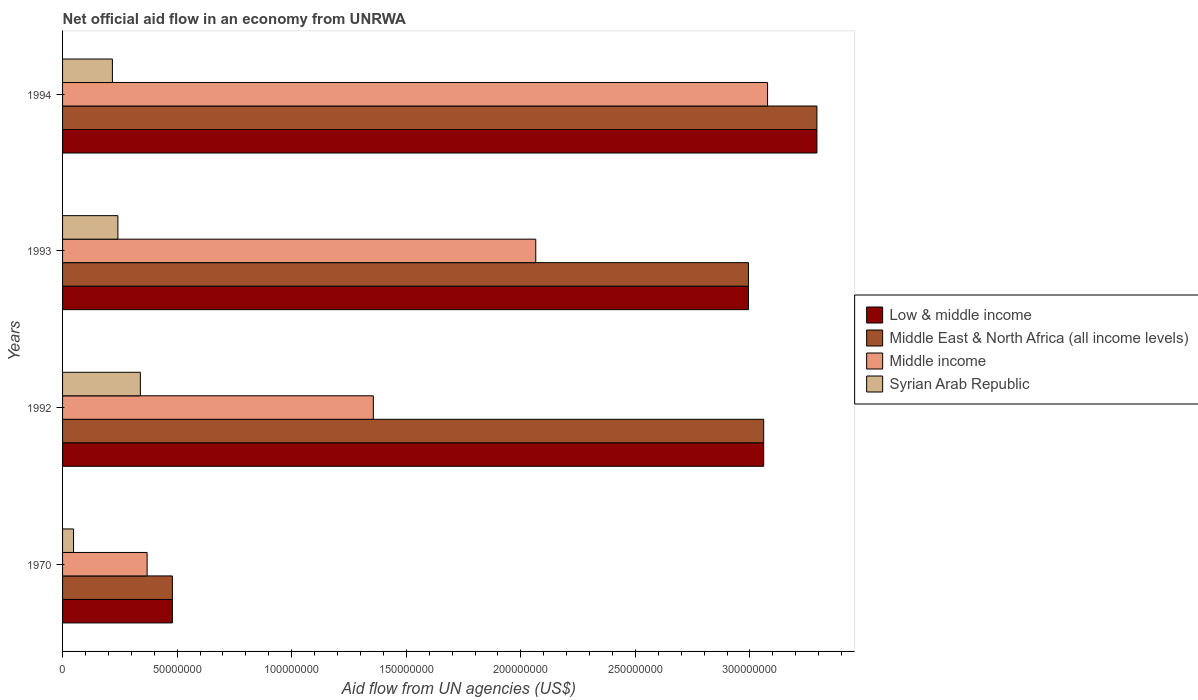How many different coloured bars are there?
Keep it short and to the point. 4. Are the number of bars per tick equal to the number of legend labels?
Provide a succinct answer. Yes. Are the number of bars on each tick of the Y-axis equal?
Your response must be concise. Yes. How many bars are there on the 4th tick from the top?
Make the answer very short. 4. How many bars are there on the 3rd tick from the bottom?
Ensure brevity in your answer.  4. What is the label of the 1st group of bars from the top?
Offer a terse response. 1994. In how many cases, is the number of bars for a given year not equal to the number of legend labels?
Your answer should be compact. 0. What is the net official aid flow in Low & middle income in 1970?
Your response must be concise. 4.79e+07. Across all years, what is the maximum net official aid flow in Syrian Arab Republic?
Your response must be concise. 3.40e+07. Across all years, what is the minimum net official aid flow in Middle East & North Africa (all income levels)?
Provide a succinct answer. 4.79e+07. In which year was the net official aid flow in Syrian Arab Republic minimum?
Offer a very short reply. 1970. What is the total net official aid flow in Syrian Arab Republic in the graph?
Make the answer very short. 8.46e+07. What is the difference between the net official aid flow in Syrian Arab Republic in 1970 and that in 1992?
Ensure brevity in your answer.  -2.92e+07. What is the difference between the net official aid flow in Middle income in 1970 and the net official aid flow in Low & middle income in 1992?
Your answer should be compact. -2.69e+08. What is the average net official aid flow in Low & middle income per year?
Your response must be concise. 2.46e+08. What is the ratio of the net official aid flow in Low & middle income in 1993 to that in 1994?
Make the answer very short. 0.91. Is the difference between the net official aid flow in Middle East & North Africa (all income levels) in 1993 and 1994 greater than the difference between the net official aid flow in Low & middle income in 1993 and 1994?
Make the answer very short. No. What is the difference between the highest and the second highest net official aid flow in Middle East & North Africa (all income levels)?
Offer a very short reply. 2.32e+07. What is the difference between the highest and the lowest net official aid flow in Middle East & North Africa (all income levels)?
Provide a short and direct response. 2.81e+08. Is the sum of the net official aid flow in Middle income in 1992 and 1993 greater than the maximum net official aid flow in Middle East & North Africa (all income levels) across all years?
Give a very brief answer. Yes. What does the 3rd bar from the top in 1970 represents?
Provide a short and direct response. Middle East & North Africa (all income levels). What does the 4th bar from the bottom in 1993 represents?
Provide a short and direct response. Syrian Arab Republic. Is it the case that in every year, the sum of the net official aid flow in Syrian Arab Republic and net official aid flow in Low & middle income is greater than the net official aid flow in Middle East & North Africa (all income levels)?
Your answer should be very brief. Yes. What is the difference between two consecutive major ticks on the X-axis?
Your answer should be very brief. 5.00e+07. Does the graph contain any zero values?
Keep it short and to the point. No. Where does the legend appear in the graph?
Offer a very short reply. Center right. How are the legend labels stacked?
Your answer should be very brief. Vertical. What is the title of the graph?
Give a very brief answer. Net official aid flow in an economy from UNRWA. What is the label or title of the X-axis?
Provide a short and direct response. Aid flow from UN agencies (US$). What is the Aid flow from UN agencies (US$) in Low & middle income in 1970?
Your answer should be very brief. 4.79e+07. What is the Aid flow from UN agencies (US$) of Middle East & North Africa (all income levels) in 1970?
Your response must be concise. 4.79e+07. What is the Aid flow from UN agencies (US$) of Middle income in 1970?
Make the answer very short. 3.69e+07. What is the Aid flow from UN agencies (US$) of Syrian Arab Republic in 1970?
Provide a short and direct response. 4.79e+06. What is the Aid flow from UN agencies (US$) of Low & middle income in 1992?
Your response must be concise. 3.06e+08. What is the Aid flow from UN agencies (US$) in Middle East & North Africa (all income levels) in 1992?
Keep it short and to the point. 3.06e+08. What is the Aid flow from UN agencies (US$) in Middle income in 1992?
Your response must be concise. 1.36e+08. What is the Aid flow from UN agencies (US$) of Syrian Arab Republic in 1992?
Give a very brief answer. 3.40e+07. What is the Aid flow from UN agencies (US$) in Low & middle income in 1993?
Ensure brevity in your answer.  2.99e+08. What is the Aid flow from UN agencies (US$) of Middle East & North Africa (all income levels) in 1993?
Ensure brevity in your answer.  2.99e+08. What is the Aid flow from UN agencies (US$) of Middle income in 1993?
Keep it short and to the point. 2.07e+08. What is the Aid flow from UN agencies (US$) in Syrian Arab Republic in 1993?
Your answer should be compact. 2.42e+07. What is the Aid flow from UN agencies (US$) in Low & middle income in 1994?
Provide a short and direct response. 3.29e+08. What is the Aid flow from UN agencies (US$) in Middle East & North Africa (all income levels) in 1994?
Provide a short and direct response. 3.29e+08. What is the Aid flow from UN agencies (US$) of Middle income in 1994?
Your answer should be very brief. 3.08e+08. What is the Aid flow from UN agencies (US$) of Syrian Arab Republic in 1994?
Offer a very short reply. 2.18e+07. Across all years, what is the maximum Aid flow from UN agencies (US$) in Low & middle income?
Make the answer very short. 3.29e+08. Across all years, what is the maximum Aid flow from UN agencies (US$) in Middle East & North Africa (all income levels)?
Provide a short and direct response. 3.29e+08. Across all years, what is the maximum Aid flow from UN agencies (US$) in Middle income?
Provide a short and direct response. 3.08e+08. Across all years, what is the maximum Aid flow from UN agencies (US$) in Syrian Arab Republic?
Provide a short and direct response. 3.40e+07. Across all years, what is the minimum Aid flow from UN agencies (US$) in Low & middle income?
Offer a very short reply. 4.79e+07. Across all years, what is the minimum Aid flow from UN agencies (US$) of Middle East & North Africa (all income levels)?
Provide a succinct answer. 4.79e+07. Across all years, what is the minimum Aid flow from UN agencies (US$) of Middle income?
Your answer should be compact. 3.69e+07. Across all years, what is the minimum Aid flow from UN agencies (US$) of Syrian Arab Republic?
Your response must be concise. 4.79e+06. What is the total Aid flow from UN agencies (US$) of Low & middle income in the graph?
Keep it short and to the point. 9.82e+08. What is the total Aid flow from UN agencies (US$) in Middle East & North Africa (all income levels) in the graph?
Make the answer very short. 9.82e+08. What is the total Aid flow from UN agencies (US$) of Middle income in the graph?
Provide a succinct answer. 6.87e+08. What is the total Aid flow from UN agencies (US$) of Syrian Arab Republic in the graph?
Make the answer very short. 8.46e+07. What is the difference between the Aid flow from UN agencies (US$) in Low & middle income in 1970 and that in 1992?
Your answer should be compact. -2.58e+08. What is the difference between the Aid flow from UN agencies (US$) in Middle East & North Africa (all income levels) in 1970 and that in 1992?
Your response must be concise. -2.58e+08. What is the difference between the Aid flow from UN agencies (US$) in Middle income in 1970 and that in 1992?
Offer a terse response. -9.87e+07. What is the difference between the Aid flow from UN agencies (US$) of Syrian Arab Republic in 1970 and that in 1992?
Your answer should be compact. -2.92e+07. What is the difference between the Aid flow from UN agencies (US$) of Low & middle income in 1970 and that in 1993?
Make the answer very short. -2.51e+08. What is the difference between the Aid flow from UN agencies (US$) of Middle East & North Africa (all income levels) in 1970 and that in 1993?
Offer a very short reply. -2.51e+08. What is the difference between the Aid flow from UN agencies (US$) of Middle income in 1970 and that in 1993?
Ensure brevity in your answer.  -1.70e+08. What is the difference between the Aid flow from UN agencies (US$) of Syrian Arab Republic in 1970 and that in 1993?
Your response must be concise. -1.94e+07. What is the difference between the Aid flow from UN agencies (US$) in Low & middle income in 1970 and that in 1994?
Make the answer very short. -2.81e+08. What is the difference between the Aid flow from UN agencies (US$) of Middle East & North Africa (all income levels) in 1970 and that in 1994?
Offer a terse response. -2.81e+08. What is the difference between the Aid flow from UN agencies (US$) in Middle income in 1970 and that in 1994?
Offer a terse response. -2.71e+08. What is the difference between the Aid flow from UN agencies (US$) of Syrian Arab Republic in 1970 and that in 1994?
Offer a very short reply. -1.70e+07. What is the difference between the Aid flow from UN agencies (US$) in Low & middle income in 1992 and that in 1993?
Keep it short and to the point. 6.65e+06. What is the difference between the Aid flow from UN agencies (US$) in Middle East & North Africa (all income levels) in 1992 and that in 1993?
Provide a short and direct response. 6.65e+06. What is the difference between the Aid flow from UN agencies (US$) of Middle income in 1992 and that in 1993?
Provide a succinct answer. -7.09e+07. What is the difference between the Aid flow from UN agencies (US$) of Syrian Arab Republic in 1992 and that in 1993?
Give a very brief answer. 9.80e+06. What is the difference between the Aid flow from UN agencies (US$) of Low & middle income in 1992 and that in 1994?
Give a very brief answer. -2.32e+07. What is the difference between the Aid flow from UN agencies (US$) in Middle East & North Africa (all income levels) in 1992 and that in 1994?
Your answer should be very brief. -2.32e+07. What is the difference between the Aid flow from UN agencies (US$) of Middle income in 1992 and that in 1994?
Provide a succinct answer. -1.72e+08. What is the difference between the Aid flow from UN agencies (US$) of Syrian Arab Republic in 1992 and that in 1994?
Give a very brief answer. 1.22e+07. What is the difference between the Aid flow from UN agencies (US$) of Low & middle income in 1993 and that in 1994?
Your response must be concise. -2.99e+07. What is the difference between the Aid flow from UN agencies (US$) of Middle East & North Africa (all income levels) in 1993 and that in 1994?
Your answer should be compact. -2.99e+07. What is the difference between the Aid flow from UN agencies (US$) of Middle income in 1993 and that in 1994?
Your answer should be compact. -1.01e+08. What is the difference between the Aid flow from UN agencies (US$) in Syrian Arab Republic in 1993 and that in 1994?
Your answer should be compact. 2.40e+06. What is the difference between the Aid flow from UN agencies (US$) of Low & middle income in 1970 and the Aid flow from UN agencies (US$) of Middle East & North Africa (all income levels) in 1992?
Your answer should be very brief. -2.58e+08. What is the difference between the Aid flow from UN agencies (US$) in Low & middle income in 1970 and the Aid flow from UN agencies (US$) in Middle income in 1992?
Ensure brevity in your answer.  -8.77e+07. What is the difference between the Aid flow from UN agencies (US$) in Low & middle income in 1970 and the Aid flow from UN agencies (US$) in Syrian Arab Republic in 1992?
Your response must be concise. 1.40e+07. What is the difference between the Aid flow from UN agencies (US$) of Middle East & North Africa (all income levels) in 1970 and the Aid flow from UN agencies (US$) of Middle income in 1992?
Ensure brevity in your answer.  -8.77e+07. What is the difference between the Aid flow from UN agencies (US$) of Middle East & North Africa (all income levels) in 1970 and the Aid flow from UN agencies (US$) of Syrian Arab Republic in 1992?
Provide a short and direct response. 1.40e+07. What is the difference between the Aid flow from UN agencies (US$) in Middle income in 1970 and the Aid flow from UN agencies (US$) in Syrian Arab Republic in 1992?
Your response must be concise. 2.95e+06. What is the difference between the Aid flow from UN agencies (US$) in Low & middle income in 1970 and the Aid flow from UN agencies (US$) in Middle East & North Africa (all income levels) in 1993?
Offer a very short reply. -2.51e+08. What is the difference between the Aid flow from UN agencies (US$) in Low & middle income in 1970 and the Aid flow from UN agencies (US$) in Middle income in 1993?
Your response must be concise. -1.59e+08. What is the difference between the Aid flow from UN agencies (US$) in Low & middle income in 1970 and the Aid flow from UN agencies (US$) in Syrian Arab Republic in 1993?
Your answer should be very brief. 2.38e+07. What is the difference between the Aid flow from UN agencies (US$) in Middle East & North Africa (all income levels) in 1970 and the Aid flow from UN agencies (US$) in Middle income in 1993?
Your response must be concise. -1.59e+08. What is the difference between the Aid flow from UN agencies (US$) in Middle East & North Africa (all income levels) in 1970 and the Aid flow from UN agencies (US$) in Syrian Arab Republic in 1993?
Offer a very short reply. 2.38e+07. What is the difference between the Aid flow from UN agencies (US$) in Middle income in 1970 and the Aid flow from UN agencies (US$) in Syrian Arab Republic in 1993?
Your answer should be very brief. 1.28e+07. What is the difference between the Aid flow from UN agencies (US$) of Low & middle income in 1970 and the Aid flow from UN agencies (US$) of Middle East & North Africa (all income levels) in 1994?
Your answer should be very brief. -2.81e+08. What is the difference between the Aid flow from UN agencies (US$) of Low & middle income in 1970 and the Aid flow from UN agencies (US$) of Middle income in 1994?
Your answer should be compact. -2.60e+08. What is the difference between the Aid flow from UN agencies (US$) in Low & middle income in 1970 and the Aid flow from UN agencies (US$) in Syrian Arab Republic in 1994?
Keep it short and to the point. 2.62e+07. What is the difference between the Aid flow from UN agencies (US$) in Middle East & North Africa (all income levels) in 1970 and the Aid flow from UN agencies (US$) in Middle income in 1994?
Your response must be concise. -2.60e+08. What is the difference between the Aid flow from UN agencies (US$) of Middle East & North Africa (all income levels) in 1970 and the Aid flow from UN agencies (US$) of Syrian Arab Republic in 1994?
Offer a very short reply. 2.62e+07. What is the difference between the Aid flow from UN agencies (US$) of Middle income in 1970 and the Aid flow from UN agencies (US$) of Syrian Arab Republic in 1994?
Your answer should be compact. 1.52e+07. What is the difference between the Aid flow from UN agencies (US$) of Low & middle income in 1992 and the Aid flow from UN agencies (US$) of Middle East & North Africa (all income levels) in 1993?
Your answer should be compact. 6.65e+06. What is the difference between the Aid flow from UN agencies (US$) in Low & middle income in 1992 and the Aid flow from UN agencies (US$) in Middle income in 1993?
Ensure brevity in your answer.  9.95e+07. What is the difference between the Aid flow from UN agencies (US$) of Low & middle income in 1992 and the Aid flow from UN agencies (US$) of Syrian Arab Republic in 1993?
Give a very brief answer. 2.82e+08. What is the difference between the Aid flow from UN agencies (US$) of Middle East & North Africa (all income levels) in 1992 and the Aid flow from UN agencies (US$) of Middle income in 1993?
Keep it short and to the point. 9.95e+07. What is the difference between the Aid flow from UN agencies (US$) of Middle East & North Africa (all income levels) in 1992 and the Aid flow from UN agencies (US$) of Syrian Arab Republic in 1993?
Give a very brief answer. 2.82e+08. What is the difference between the Aid flow from UN agencies (US$) in Middle income in 1992 and the Aid flow from UN agencies (US$) in Syrian Arab Republic in 1993?
Ensure brevity in your answer.  1.11e+08. What is the difference between the Aid flow from UN agencies (US$) in Low & middle income in 1992 and the Aid flow from UN agencies (US$) in Middle East & North Africa (all income levels) in 1994?
Provide a succinct answer. -2.32e+07. What is the difference between the Aid flow from UN agencies (US$) of Low & middle income in 1992 and the Aid flow from UN agencies (US$) of Middle income in 1994?
Give a very brief answer. -1.70e+06. What is the difference between the Aid flow from UN agencies (US$) in Low & middle income in 1992 and the Aid flow from UN agencies (US$) in Syrian Arab Republic in 1994?
Your response must be concise. 2.84e+08. What is the difference between the Aid flow from UN agencies (US$) in Middle East & North Africa (all income levels) in 1992 and the Aid flow from UN agencies (US$) in Middle income in 1994?
Provide a succinct answer. -1.70e+06. What is the difference between the Aid flow from UN agencies (US$) in Middle East & North Africa (all income levels) in 1992 and the Aid flow from UN agencies (US$) in Syrian Arab Republic in 1994?
Provide a succinct answer. 2.84e+08. What is the difference between the Aid flow from UN agencies (US$) of Middle income in 1992 and the Aid flow from UN agencies (US$) of Syrian Arab Republic in 1994?
Your answer should be compact. 1.14e+08. What is the difference between the Aid flow from UN agencies (US$) in Low & middle income in 1993 and the Aid flow from UN agencies (US$) in Middle East & North Africa (all income levels) in 1994?
Provide a succinct answer. -2.99e+07. What is the difference between the Aid flow from UN agencies (US$) of Low & middle income in 1993 and the Aid flow from UN agencies (US$) of Middle income in 1994?
Your answer should be compact. -8.35e+06. What is the difference between the Aid flow from UN agencies (US$) of Low & middle income in 1993 and the Aid flow from UN agencies (US$) of Syrian Arab Republic in 1994?
Offer a very short reply. 2.78e+08. What is the difference between the Aid flow from UN agencies (US$) in Middle East & North Africa (all income levels) in 1993 and the Aid flow from UN agencies (US$) in Middle income in 1994?
Provide a succinct answer. -8.35e+06. What is the difference between the Aid flow from UN agencies (US$) in Middle East & North Africa (all income levels) in 1993 and the Aid flow from UN agencies (US$) in Syrian Arab Republic in 1994?
Give a very brief answer. 2.78e+08. What is the difference between the Aid flow from UN agencies (US$) of Middle income in 1993 and the Aid flow from UN agencies (US$) of Syrian Arab Republic in 1994?
Ensure brevity in your answer.  1.85e+08. What is the average Aid flow from UN agencies (US$) of Low & middle income per year?
Offer a terse response. 2.46e+08. What is the average Aid flow from UN agencies (US$) in Middle East & North Africa (all income levels) per year?
Give a very brief answer. 2.46e+08. What is the average Aid flow from UN agencies (US$) of Middle income per year?
Provide a short and direct response. 1.72e+08. What is the average Aid flow from UN agencies (US$) in Syrian Arab Republic per year?
Your answer should be very brief. 2.12e+07. In the year 1970, what is the difference between the Aid flow from UN agencies (US$) in Low & middle income and Aid flow from UN agencies (US$) in Middle income?
Make the answer very short. 1.10e+07. In the year 1970, what is the difference between the Aid flow from UN agencies (US$) in Low & middle income and Aid flow from UN agencies (US$) in Syrian Arab Republic?
Provide a short and direct response. 4.31e+07. In the year 1970, what is the difference between the Aid flow from UN agencies (US$) in Middle East & North Africa (all income levels) and Aid flow from UN agencies (US$) in Middle income?
Make the answer very short. 1.10e+07. In the year 1970, what is the difference between the Aid flow from UN agencies (US$) in Middle East & North Africa (all income levels) and Aid flow from UN agencies (US$) in Syrian Arab Republic?
Ensure brevity in your answer.  4.31e+07. In the year 1970, what is the difference between the Aid flow from UN agencies (US$) in Middle income and Aid flow from UN agencies (US$) in Syrian Arab Republic?
Your response must be concise. 3.21e+07. In the year 1992, what is the difference between the Aid flow from UN agencies (US$) in Low & middle income and Aid flow from UN agencies (US$) in Middle income?
Offer a terse response. 1.70e+08. In the year 1992, what is the difference between the Aid flow from UN agencies (US$) of Low & middle income and Aid flow from UN agencies (US$) of Syrian Arab Republic?
Give a very brief answer. 2.72e+08. In the year 1992, what is the difference between the Aid flow from UN agencies (US$) of Middle East & North Africa (all income levels) and Aid flow from UN agencies (US$) of Middle income?
Offer a very short reply. 1.70e+08. In the year 1992, what is the difference between the Aid flow from UN agencies (US$) of Middle East & North Africa (all income levels) and Aid flow from UN agencies (US$) of Syrian Arab Republic?
Ensure brevity in your answer.  2.72e+08. In the year 1992, what is the difference between the Aid flow from UN agencies (US$) of Middle income and Aid flow from UN agencies (US$) of Syrian Arab Republic?
Your answer should be compact. 1.02e+08. In the year 1993, what is the difference between the Aid flow from UN agencies (US$) of Low & middle income and Aid flow from UN agencies (US$) of Middle East & North Africa (all income levels)?
Your response must be concise. 0. In the year 1993, what is the difference between the Aid flow from UN agencies (US$) in Low & middle income and Aid flow from UN agencies (US$) in Middle income?
Ensure brevity in your answer.  9.28e+07. In the year 1993, what is the difference between the Aid flow from UN agencies (US$) in Low & middle income and Aid flow from UN agencies (US$) in Syrian Arab Republic?
Provide a succinct answer. 2.75e+08. In the year 1993, what is the difference between the Aid flow from UN agencies (US$) in Middle East & North Africa (all income levels) and Aid flow from UN agencies (US$) in Middle income?
Provide a short and direct response. 9.28e+07. In the year 1993, what is the difference between the Aid flow from UN agencies (US$) in Middle East & North Africa (all income levels) and Aid flow from UN agencies (US$) in Syrian Arab Republic?
Give a very brief answer. 2.75e+08. In the year 1993, what is the difference between the Aid flow from UN agencies (US$) in Middle income and Aid flow from UN agencies (US$) in Syrian Arab Republic?
Your response must be concise. 1.82e+08. In the year 1994, what is the difference between the Aid flow from UN agencies (US$) in Low & middle income and Aid flow from UN agencies (US$) in Middle income?
Offer a very short reply. 2.15e+07. In the year 1994, what is the difference between the Aid flow from UN agencies (US$) in Low & middle income and Aid flow from UN agencies (US$) in Syrian Arab Republic?
Your answer should be very brief. 3.07e+08. In the year 1994, what is the difference between the Aid flow from UN agencies (US$) in Middle East & North Africa (all income levels) and Aid flow from UN agencies (US$) in Middle income?
Provide a short and direct response. 2.15e+07. In the year 1994, what is the difference between the Aid flow from UN agencies (US$) of Middle East & North Africa (all income levels) and Aid flow from UN agencies (US$) of Syrian Arab Republic?
Your response must be concise. 3.07e+08. In the year 1994, what is the difference between the Aid flow from UN agencies (US$) of Middle income and Aid flow from UN agencies (US$) of Syrian Arab Republic?
Your response must be concise. 2.86e+08. What is the ratio of the Aid flow from UN agencies (US$) in Low & middle income in 1970 to that in 1992?
Offer a terse response. 0.16. What is the ratio of the Aid flow from UN agencies (US$) of Middle East & North Africa (all income levels) in 1970 to that in 1992?
Provide a short and direct response. 0.16. What is the ratio of the Aid flow from UN agencies (US$) of Middle income in 1970 to that in 1992?
Ensure brevity in your answer.  0.27. What is the ratio of the Aid flow from UN agencies (US$) in Syrian Arab Republic in 1970 to that in 1992?
Ensure brevity in your answer.  0.14. What is the ratio of the Aid flow from UN agencies (US$) of Low & middle income in 1970 to that in 1993?
Provide a short and direct response. 0.16. What is the ratio of the Aid flow from UN agencies (US$) in Middle East & North Africa (all income levels) in 1970 to that in 1993?
Ensure brevity in your answer.  0.16. What is the ratio of the Aid flow from UN agencies (US$) in Middle income in 1970 to that in 1993?
Provide a short and direct response. 0.18. What is the ratio of the Aid flow from UN agencies (US$) of Syrian Arab Republic in 1970 to that in 1993?
Make the answer very short. 0.2. What is the ratio of the Aid flow from UN agencies (US$) of Low & middle income in 1970 to that in 1994?
Give a very brief answer. 0.15. What is the ratio of the Aid flow from UN agencies (US$) of Middle East & North Africa (all income levels) in 1970 to that in 1994?
Your answer should be compact. 0.15. What is the ratio of the Aid flow from UN agencies (US$) of Middle income in 1970 to that in 1994?
Give a very brief answer. 0.12. What is the ratio of the Aid flow from UN agencies (US$) of Syrian Arab Republic in 1970 to that in 1994?
Ensure brevity in your answer.  0.22. What is the ratio of the Aid flow from UN agencies (US$) in Low & middle income in 1992 to that in 1993?
Make the answer very short. 1.02. What is the ratio of the Aid flow from UN agencies (US$) in Middle East & North Africa (all income levels) in 1992 to that in 1993?
Offer a very short reply. 1.02. What is the ratio of the Aid flow from UN agencies (US$) of Middle income in 1992 to that in 1993?
Give a very brief answer. 0.66. What is the ratio of the Aid flow from UN agencies (US$) of Syrian Arab Republic in 1992 to that in 1993?
Your answer should be very brief. 1.41. What is the ratio of the Aid flow from UN agencies (US$) in Low & middle income in 1992 to that in 1994?
Your answer should be very brief. 0.93. What is the ratio of the Aid flow from UN agencies (US$) of Middle East & North Africa (all income levels) in 1992 to that in 1994?
Offer a terse response. 0.93. What is the ratio of the Aid flow from UN agencies (US$) in Middle income in 1992 to that in 1994?
Provide a succinct answer. 0.44. What is the ratio of the Aid flow from UN agencies (US$) in Syrian Arab Republic in 1992 to that in 1994?
Your answer should be very brief. 1.56. What is the ratio of the Aid flow from UN agencies (US$) in Low & middle income in 1993 to that in 1994?
Offer a very short reply. 0.91. What is the ratio of the Aid flow from UN agencies (US$) in Middle East & North Africa (all income levels) in 1993 to that in 1994?
Provide a succinct answer. 0.91. What is the ratio of the Aid flow from UN agencies (US$) in Middle income in 1993 to that in 1994?
Your response must be concise. 0.67. What is the ratio of the Aid flow from UN agencies (US$) in Syrian Arab Republic in 1993 to that in 1994?
Ensure brevity in your answer.  1.11. What is the difference between the highest and the second highest Aid flow from UN agencies (US$) in Low & middle income?
Your answer should be compact. 2.32e+07. What is the difference between the highest and the second highest Aid flow from UN agencies (US$) of Middle East & North Africa (all income levels)?
Offer a terse response. 2.32e+07. What is the difference between the highest and the second highest Aid flow from UN agencies (US$) of Middle income?
Your answer should be very brief. 1.01e+08. What is the difference between the highest and the second highest Aid flow from UN agencies (US$) in Syrian Arab Republic?
Provide a succinct answer. 9.80e+06. What is the difference between the highest and the lowest Aid flow from UN agencies (US$) of Low & middle income?
Offer a very short reply. 2.81e+08. What is the difference between the highest and the lowest Aid flow from UN agencies (US$) of Middle East & North Africa (all income levels)?
Offer a very short reply. 2.81e+08. What is the difference between the highest and the lowest Aid flow from UN agencies (US$) in Middle income?
Provide a succinct answer. 2.71e+08. What is the difference between the highest and the lowest Aid flow from UN agencies (US$) of Syrian Arab Republic?
Your answer should be compact. 2.92e+07. 